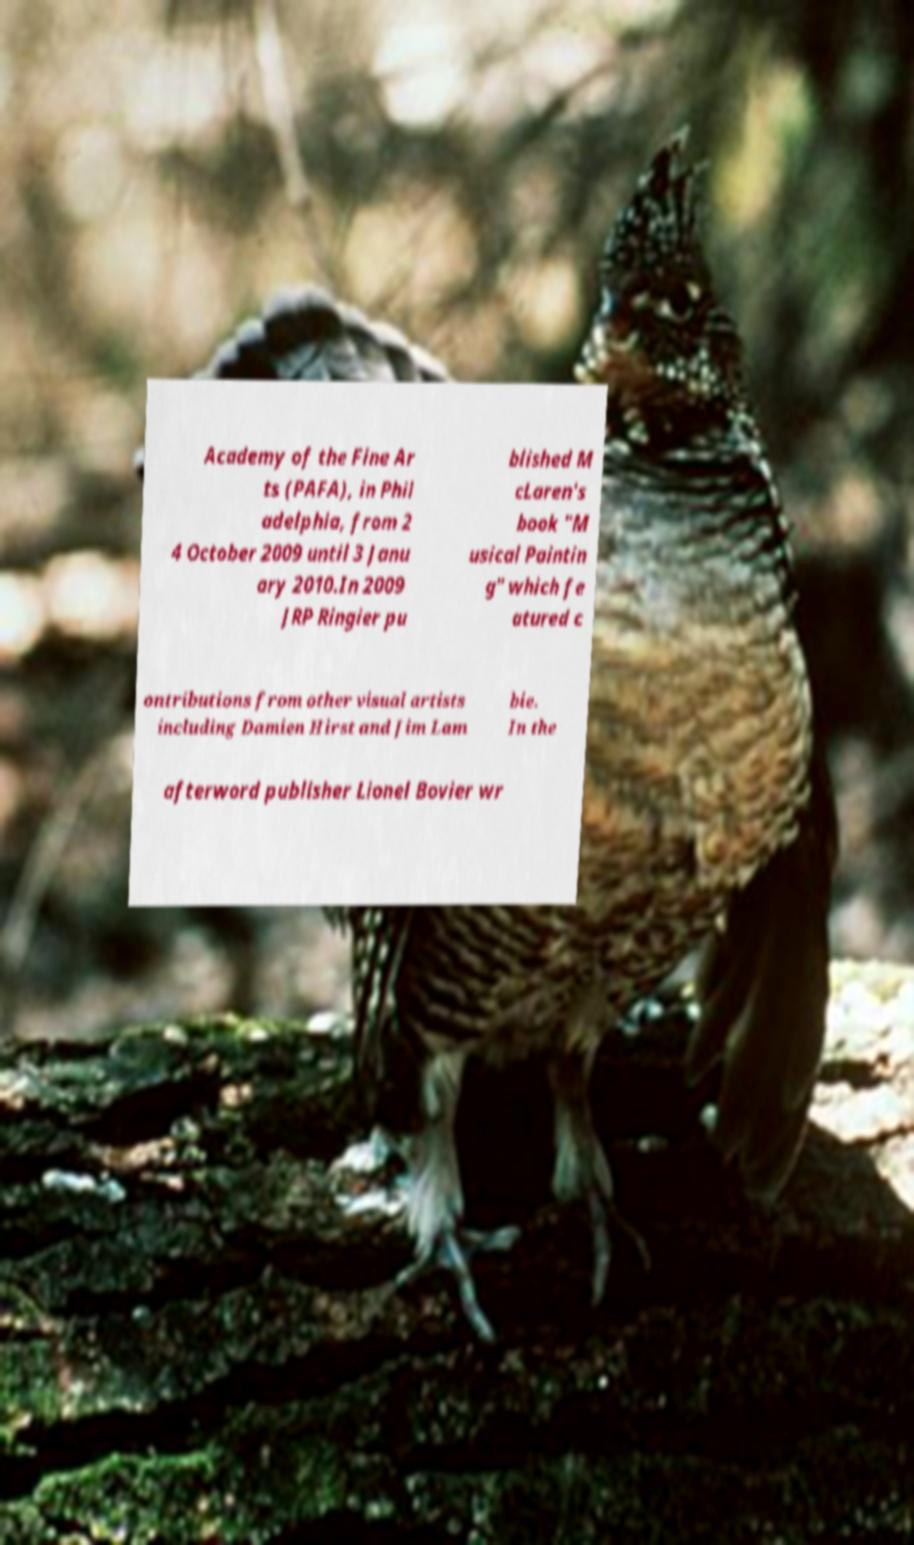I need the written content from this picture converted into text. Can you do that? Academy of the Fine Ar ts (PAFA), in Phil adelphia, from 2 4 October 2009 until 3 Janu ary 2010.In 2009 JRP Ringier pu blished M cLaren's book "M usical Paintin g" which fe atured c ontributions from other visual artists including Damien Hirst and Jim Lam bie. In the afterword publisher Lionel Bovier wr 